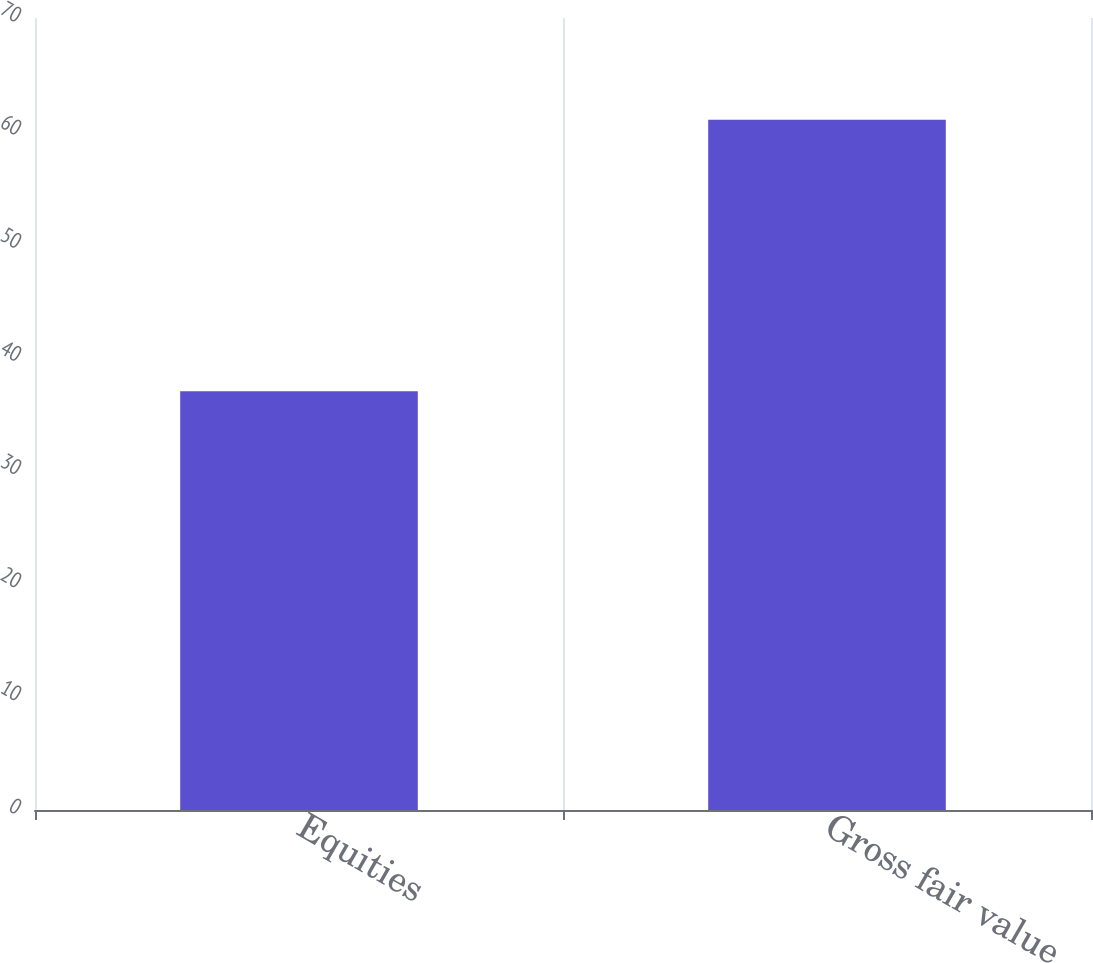Convert chart. <chart><loc_0><loc_0><loc_500><loc_500><bar_chart><fcel>Equities<fcel>Gross fair value<nl><fcel>37<fcel>61<nl></chart> 